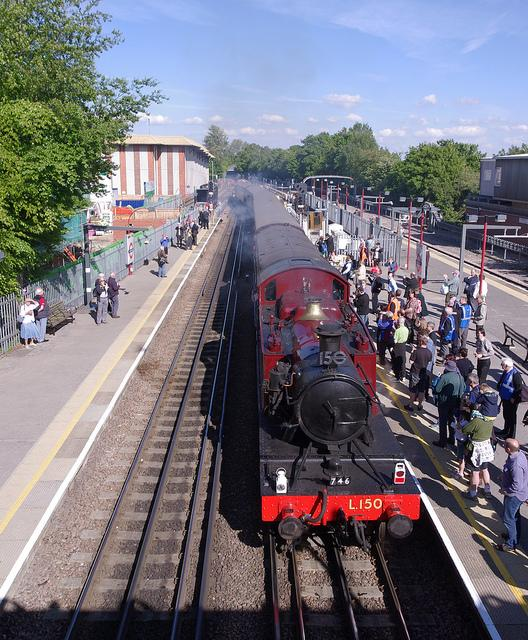What is the gold object near the front of the train? bell 